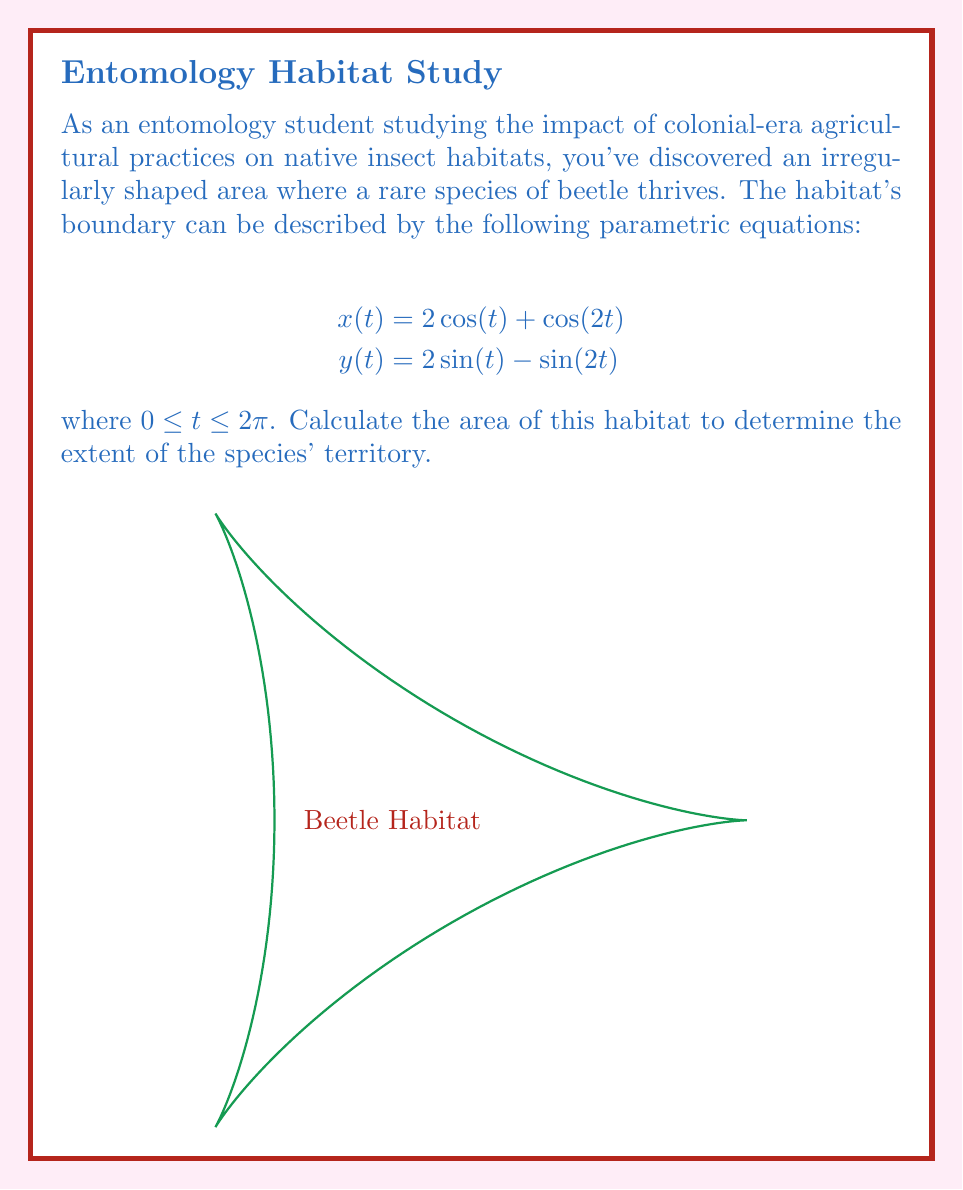Can you answer this question? To calculate the area enclosed by a parametric curve, we can use the formula:

$$\text{Area} = \frac{1}{2}\int_{0}^{2\pi} [x(t)y'(t) - y(t)x'(t)] dt$$

Step 1: Calculate $x'(t)$ and $y'(t)$
$$x'(t) = -2\sin(t) - 2\sin(2t)$$
$$y'(t) = 2\cos(t) - 2\cos(2t)$$

Step 2: Substitute into the area formula
$$\text{Area} = \frac{1}{2}\int_{0}^{2\pi} [(2\cos(t) + \cos(2t))(2\cos(t) - 2\cos(2t)) - (2\sin(t) - \sin(2t))(-2\sin(t) - 2\sin(2t))] dt$$

Step 3: Expand the expression
$$\text{Area} = \frac{1}{2}\int_{0}^{2\pi} [4\cos^2(t) - 4\cos(t)\cos(2t) + 2\cos(t)\cos(2t) - 2\cos^2(2t) + 4\sin^2(t) + 4\sin(t)\sin(2t) - 2\sin(t)\sin(2t)] dt$$

Step 4: Simplify using trigonometric identities
$$\text{Area} = \frac{1}{2}\int_{0}^{2\pi} [4\cos^2(t) + 4\sin^2(t) - 2\cos(t)\cos(2t) + 2\sin(t)\sin(2t) - 2\cos^2(2t)] dt$$
$$\text{Area} = \frac{1}{2}\int_{0}^{2\pi} [4 - 2\cos(3t) - 2\cos^2(2t)] dt$$

Step 5: Integrate
$$\text{Area} = \frac{1}{2}[4t - \frac{2}{3}\sin(3t) - t - \frac{1}{4}\sin(4t)]_0^{2\pi}$$

Step 6: Evaluate the definite integral
$$\text{Area} = \frac{1}{2}[8\pi - 2\pi] = 3\pi$$

Therefore, the area of the beetle habitat is $3\pi$ square units.
Answer: $3\pi$ square units 